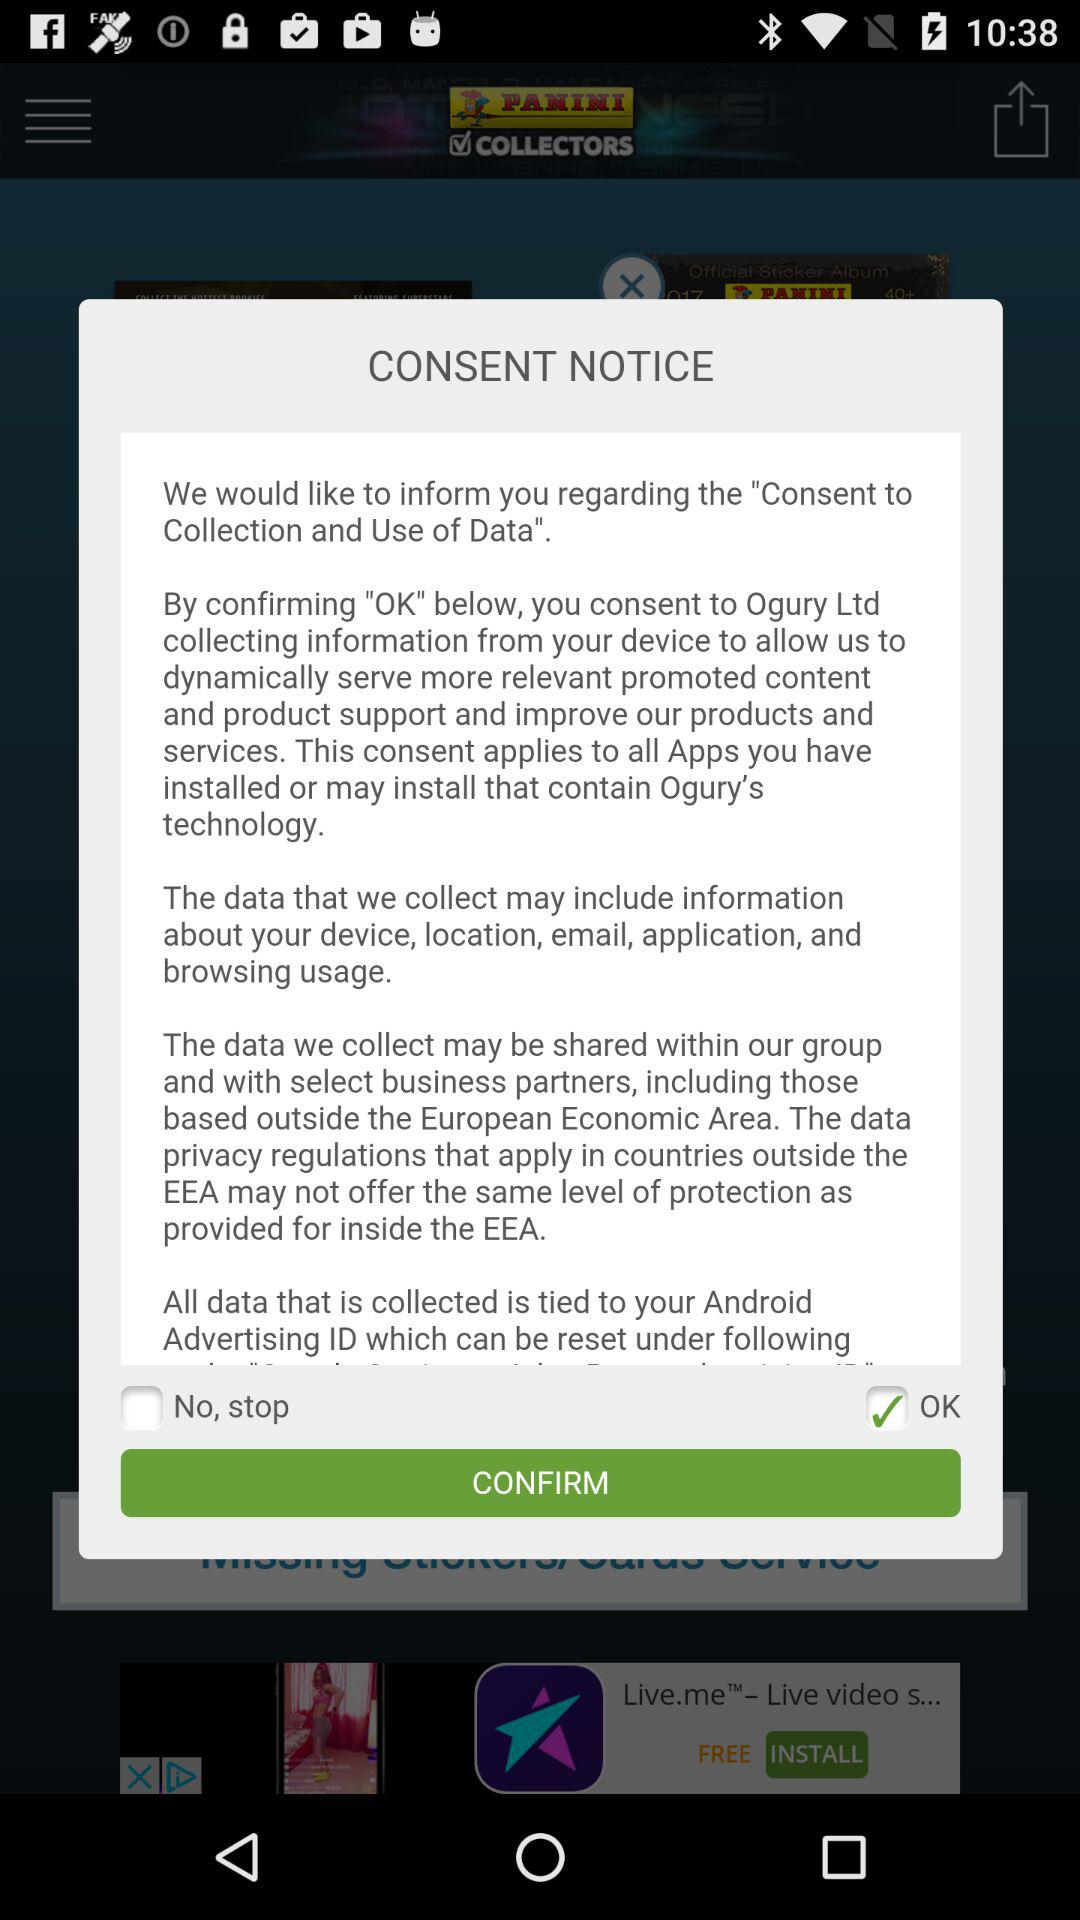What is the status of "No, stop"? The status is "off". 